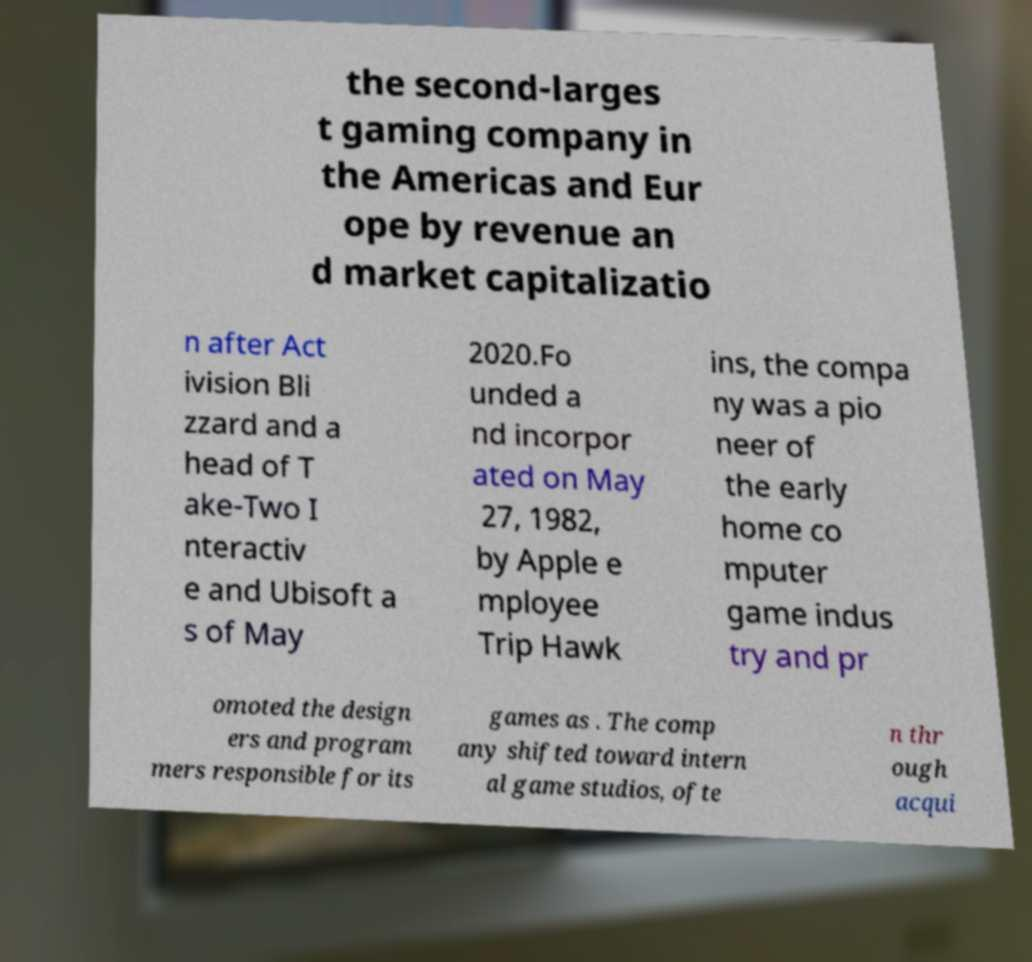Can you read and provide the text displayed in the image?This photo seems to have some interesting text. Can you extract and type it out for me? the second-larges t gaming company in the Americas and Eur ope by revenue an d market capitalizatio n after Act ivision Bli zzard and a head of T ake-Two I nteractiv e and Ubisoft a s of May 2020.Fo unded a nd incorpor ated on May 27, 1982, by Apple e mployee Trip Hawk ins, the compa ny was a pio neer of the early home co mputer game indus try and pr omoted the design ers and program mers responsible for its games as . The comp any shifted toward intern al game studios, ofte n thr ough acqui 